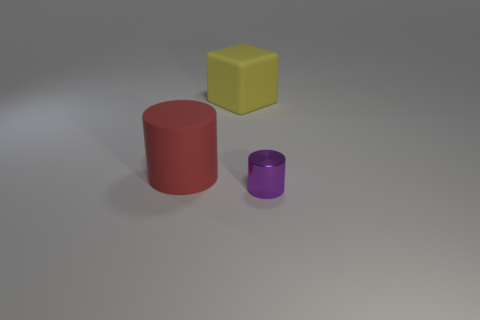Subtract 1 cubes. How many cubes are left? 0 Subtract all blue cylinders. Subtract all brown cubes. How many cylinders are left? 2 Subtract all purple cubes. How many red cylinders are left? 1 Subtract all red things. Subtract all purple metal cylinders. How many objects are left? 1 Add 3 large rubber objects. How many large rubber objects are left? 5 Add 3 tiny brown objects. How many tiny brown objects exist? 3 Add 3 small metallic things. How many objects exist? 6 Subtract 0 red balls. How many objects are left? 3 Subtract all cylinders. How many objects are left? 1 